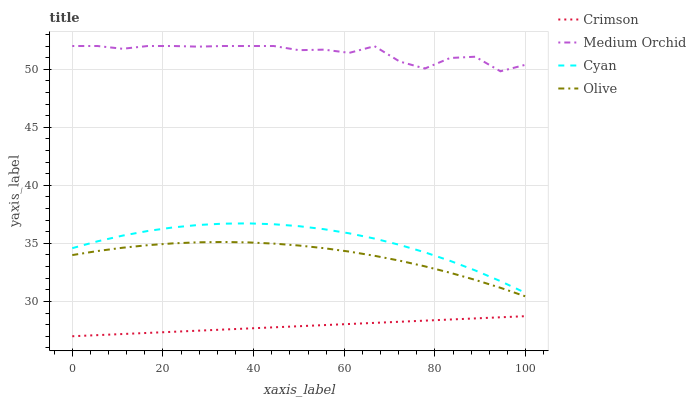Does Cyan have the minimum area under the curve?
Answer yes or no. No. Does Cyan have the maximum area under the curve?
Answer yes or no. No. Is Cyan the smoothest?
Answer yes or no. No. Is Cyan the roughest?
Answer yes or no. No. Does Cyan have the lowest value?
Answer yes or no. No. Does Cyan have the highest value?
Answer yes or no. No. Is Olive less than Cyan?
Answer yes or no. Yes. Is Cyan greater than Olive?
Answer yes or no. Yes. Does Olive intersect Cyan?
Answer yes or no. No. 